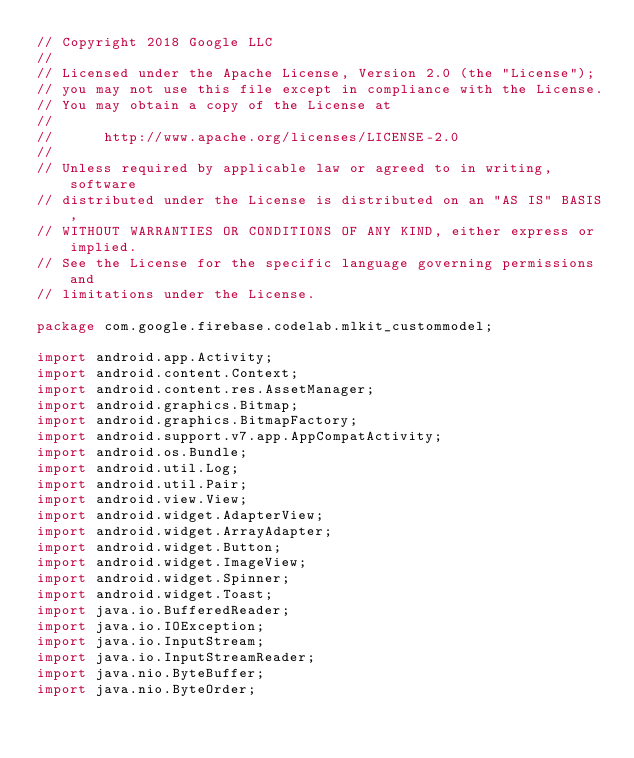<code> <loc_0><loc_0><loc_500><loc_500><_Java_>// Copyright 2018 Google LLC
//
// Licensed under the Apache License, Version 2.0 (the "License");
// you may not use this file except in compliance with the License.
// You may obtain a copy of the License at
//
//      http://www.apache.org/licenses/LICENSE-2.0
//
// Unless required by applicable law or agreed to in writing, software
// distributed under the License is distributed on an "AS IS" BASIS,
// WITHOUT WARRANTIES OR CONDITIONS OF ANY KIND, either express or implied.
// See the License for the specific language governing permissions and
// limitations under the License.

package com.google.firebase.codelab.mlkit_custommodel;

import android.app.Activity;
import android.content.Context;
import android.content.res.AssetManager;
import android.graphics.Bitmap;
import android.graphics.BitmapFactory;
import android.support.v7.app.AppCompatActivity;
import android.os.Bundle;
import android.util.Log;
import android.util.Pair;
import android.view.View;
import android.widget.AdapterView;
import android.widget.ArrayAdapter;
import android.widget.Button;
import android.widget.ImageView;
import android.widget.Spinner;
import android.widget.Toast;
import java.io.BufferedReader;
import java.io.IOException;
import java.io.InputStream;
import java.io.InputStreamReader;
import java.nio.ByteBuffer;
import java.nio.ByteOrder;</code> 